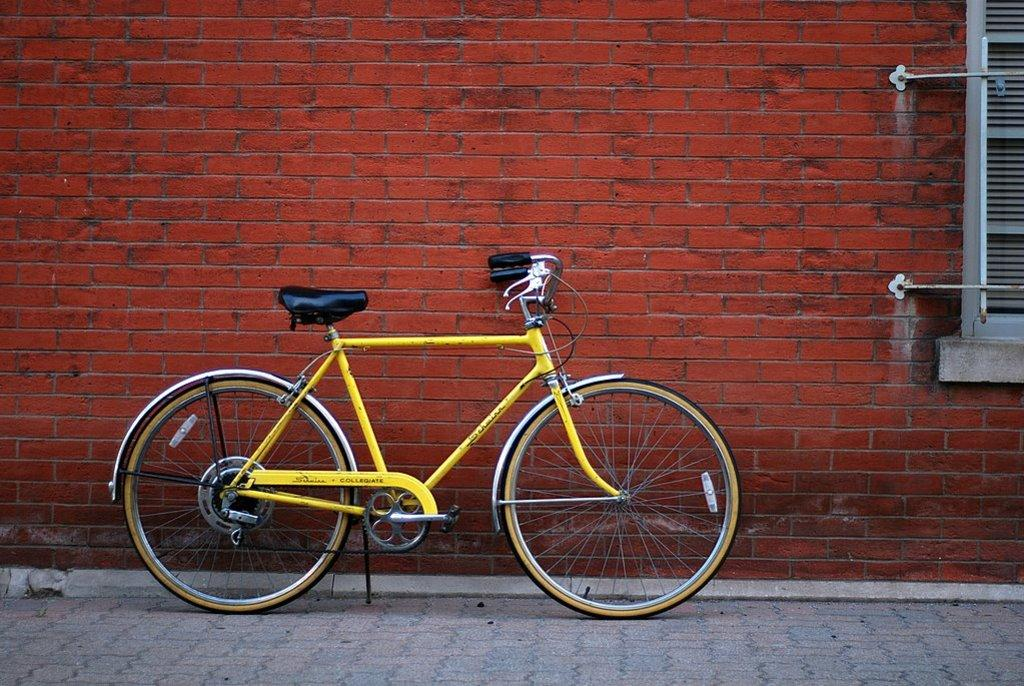What color is the bicycle in the image? The bicycle in the image is yellow. Where is the bicycle located in the image? The bicycle is in the middle of the image. What can be seen in the background of the image? There is a wall and a window in the background of the image. What type of note is attached to the bicycle in the image? There is no note attached to the bicycle in the image. What kind of apparatus is used to ride the bicycle in the image? The bicycle in the image does not require any additional apparatus to ride, as it is a standard bicycle. 